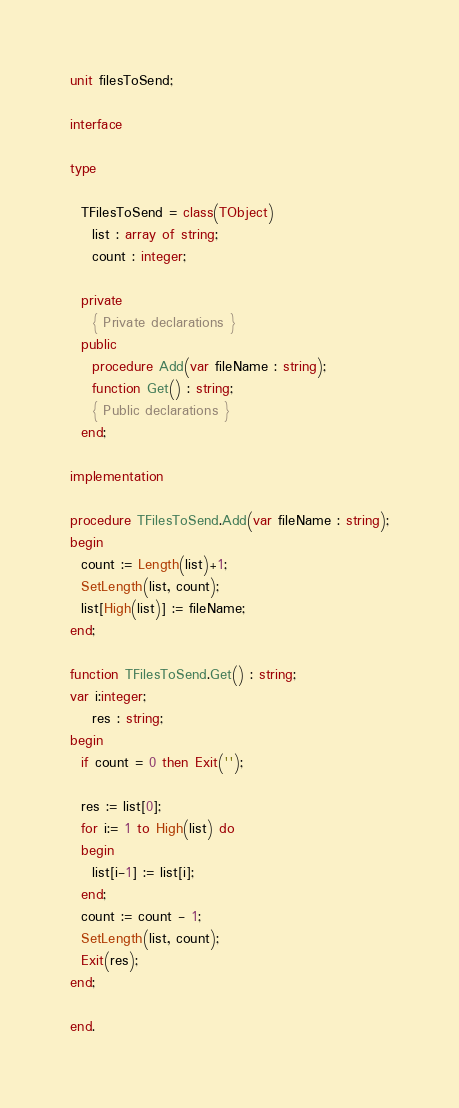<code> <loc_0><loc_0><loc_500><loc_500><_Pascal_>unit filesToSend;

interface

type

  TFilesToSend = class(TObject)
    list : array of string;
    count : integer;

  private
    { Private declarations }
  public
    procedure Add(var fileName : string);
    function Get() : string;
    { Public declarations }
  end;

implementation

procedure TFilesToSend.Add(var fileName : string);
begin
  count := Length(list)+1;
  SetLength(list, count);
  list[High(list)] := fileName;
end;

function TFilesToSend.Get() : string;
var i:integer;
    res : string;
begin
  if count = 0 then Exit('');

  res := list[0];
  for i:= 1 to High(list) do
  begin
    list[i-1] := list[i];
  end;
  count := count - 1;
  SetLength(list, count);
  Exit(res);
end;

end.
</code> 